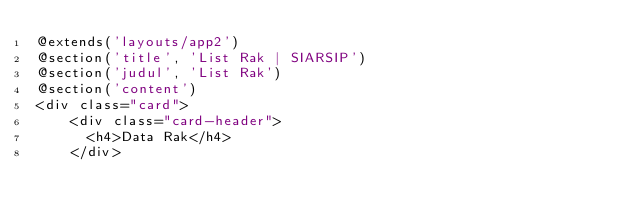Convert code to text. <code><loc_0><loc_0><loc_500><loc_500><_PHP_>@extends('layouts/app2')
@section('title', 'List Rak | SIARSIP')
@section('judul', 'List Rak')
@section('content')
<div class="card">
    <div class="card-header">
      <h4>Data Rak</h4>
    </div></code> 